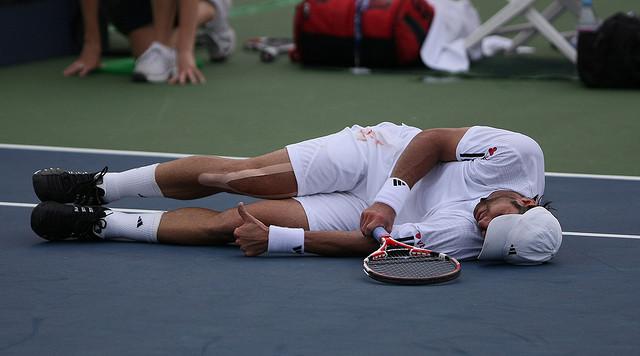What does the closest man have around his head?
Write a very short answer. Hat. Has the man lost his balance and tipped over?
Answer briefly. Yes. What is the brand of clothes the man is wearing?
Answer briefly. Adidas. Why is this man giving the thumbs up sign?
Concise answer only. He's ok. What color is the stripe on the  man's shirt holding the racquet?
Short answer required. Black. 